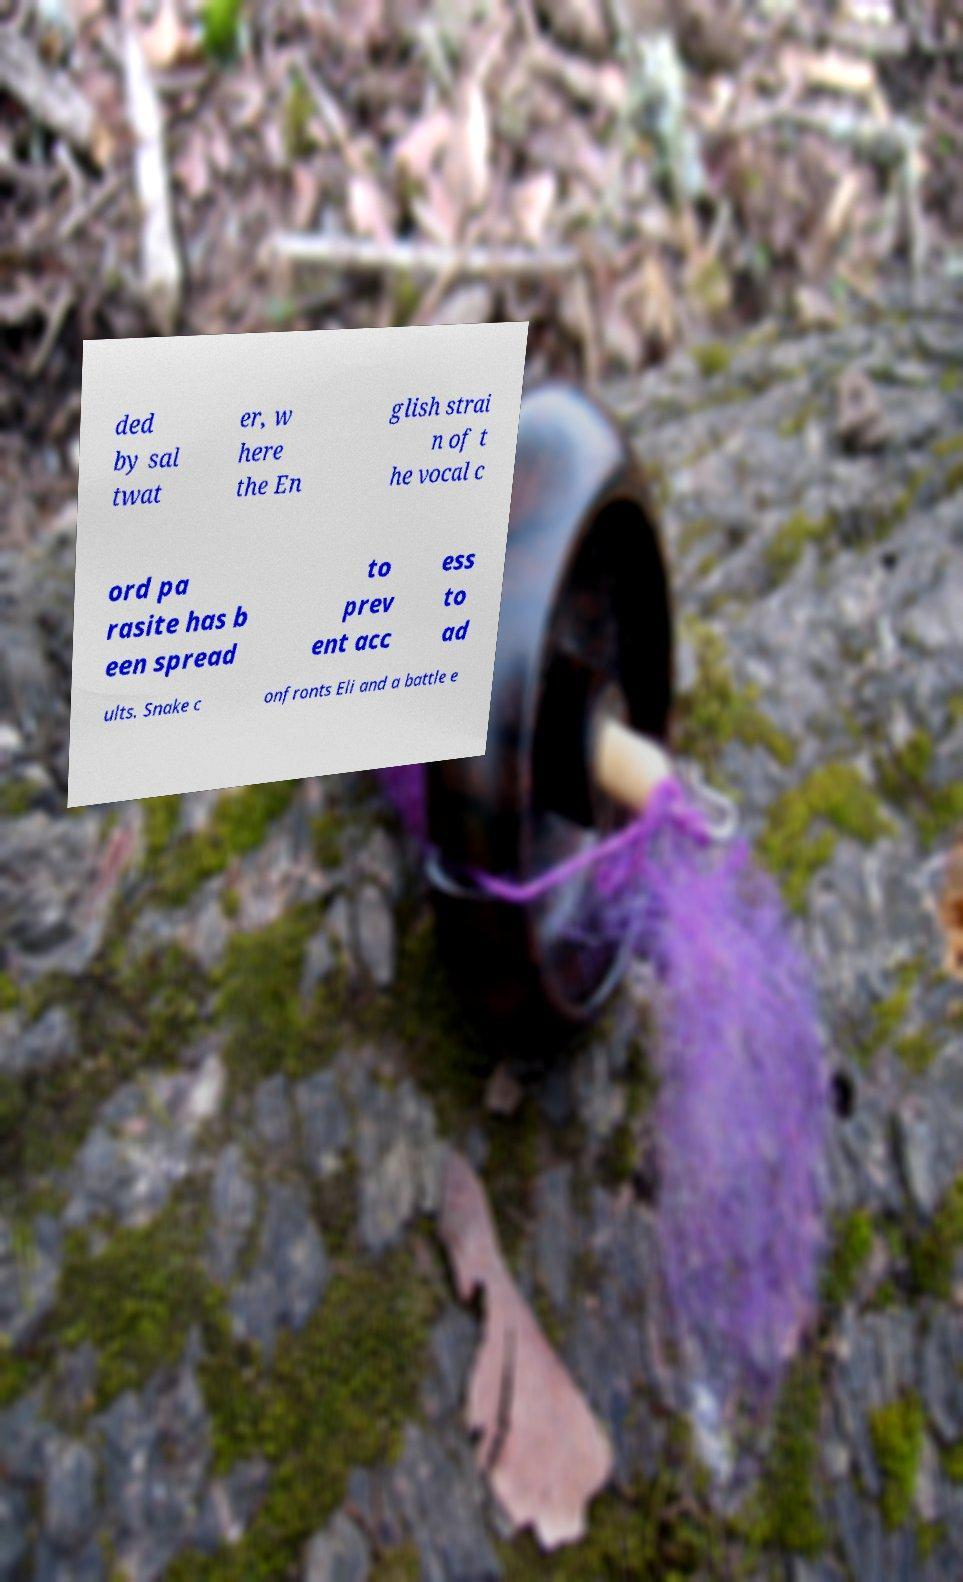For documentation purposes, I need the text within this image transcribed. Could you provide that? ded by sal twat er, w here the En glish strai n of t he vocal c ord pa rasite has b een spread to prev ent acc ess to ad ults. Snake c onfronts Eli and a battle e 